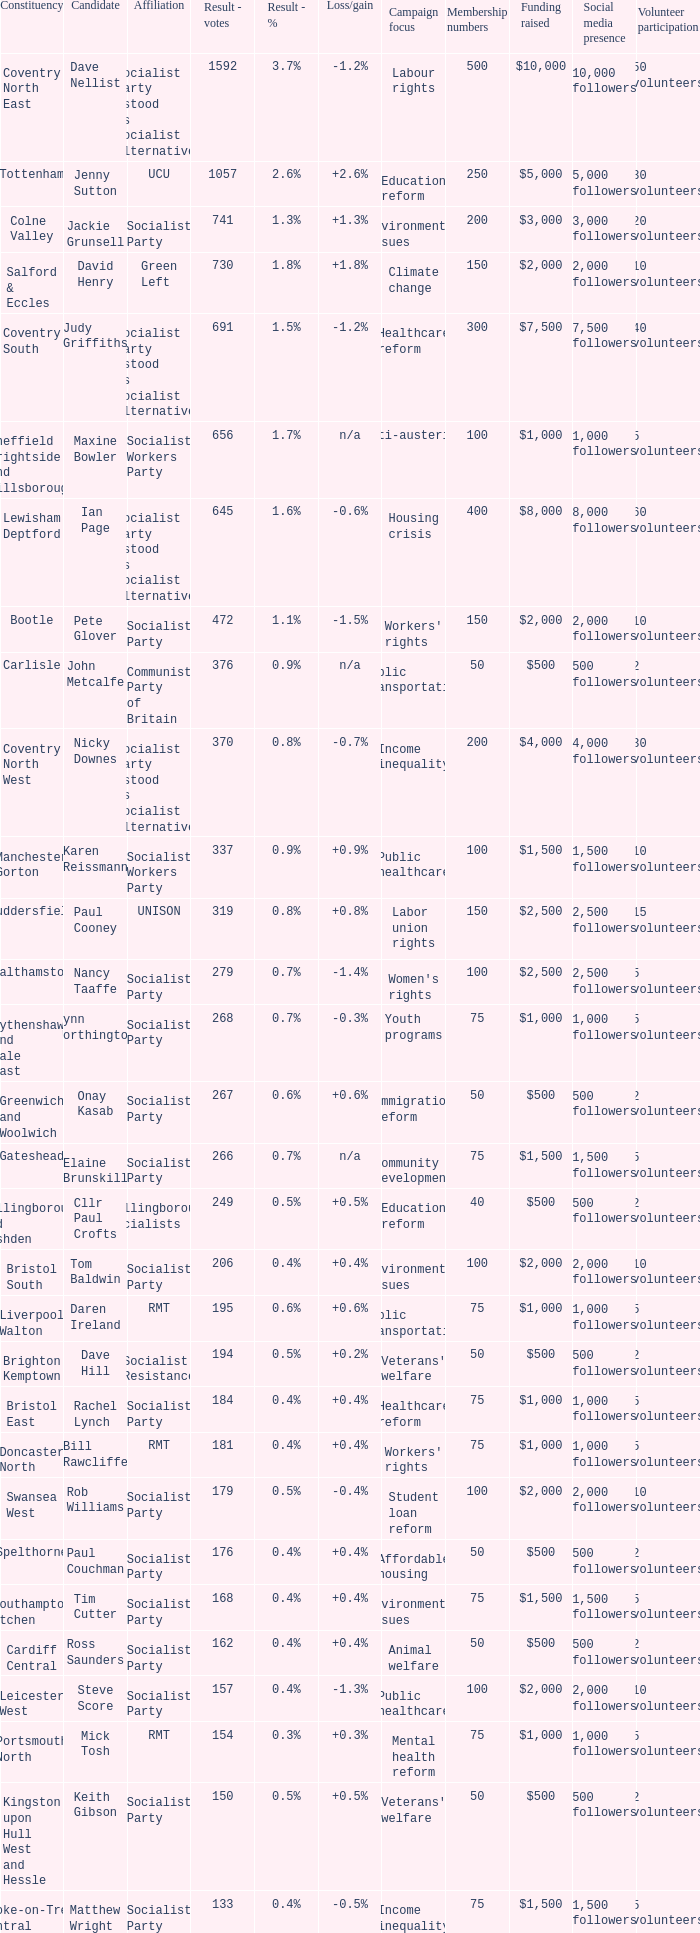What are all the ties for candidate daren ireland? RMT. 